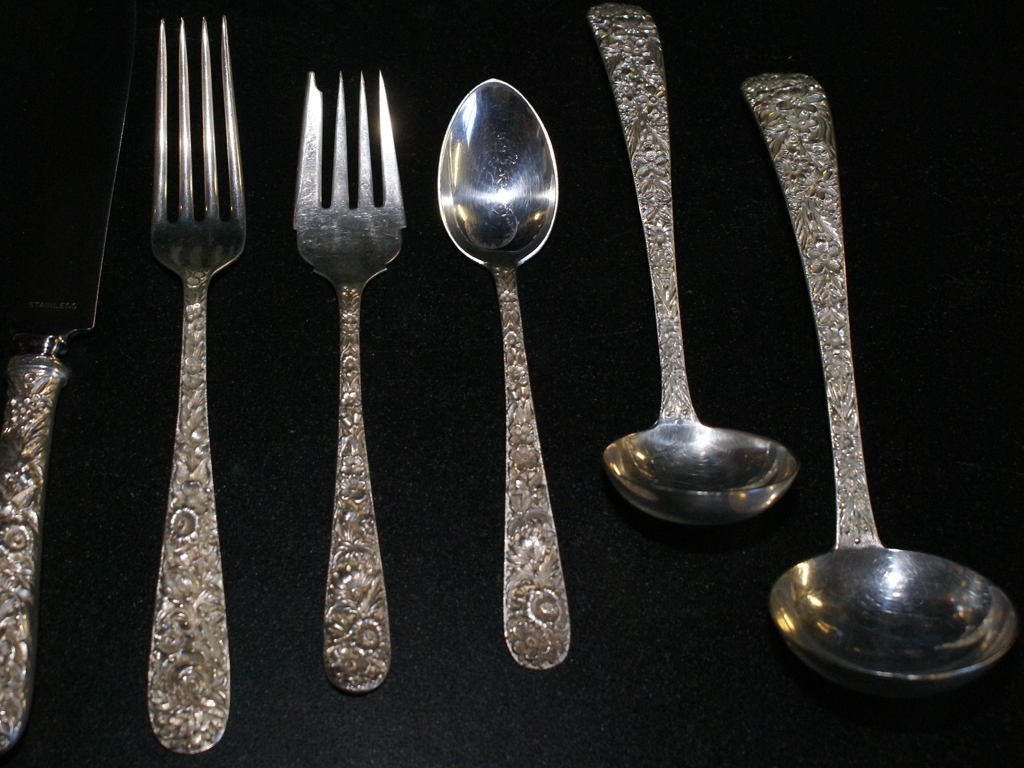What material do you think the cutlery is made of? The reflective sheen and the ornate handles suggest that the cutlery may be made of polished silver or high-quality stainless steel, both of which are commonly used for formal dining ware. How can one maintain such cutlery? To maintain the luster of silver or stainless steel cutlery, it's important to hand wash them after use, dry immediately to prevent water spots, and polish them occasionally with a suitable cleaning agent. 